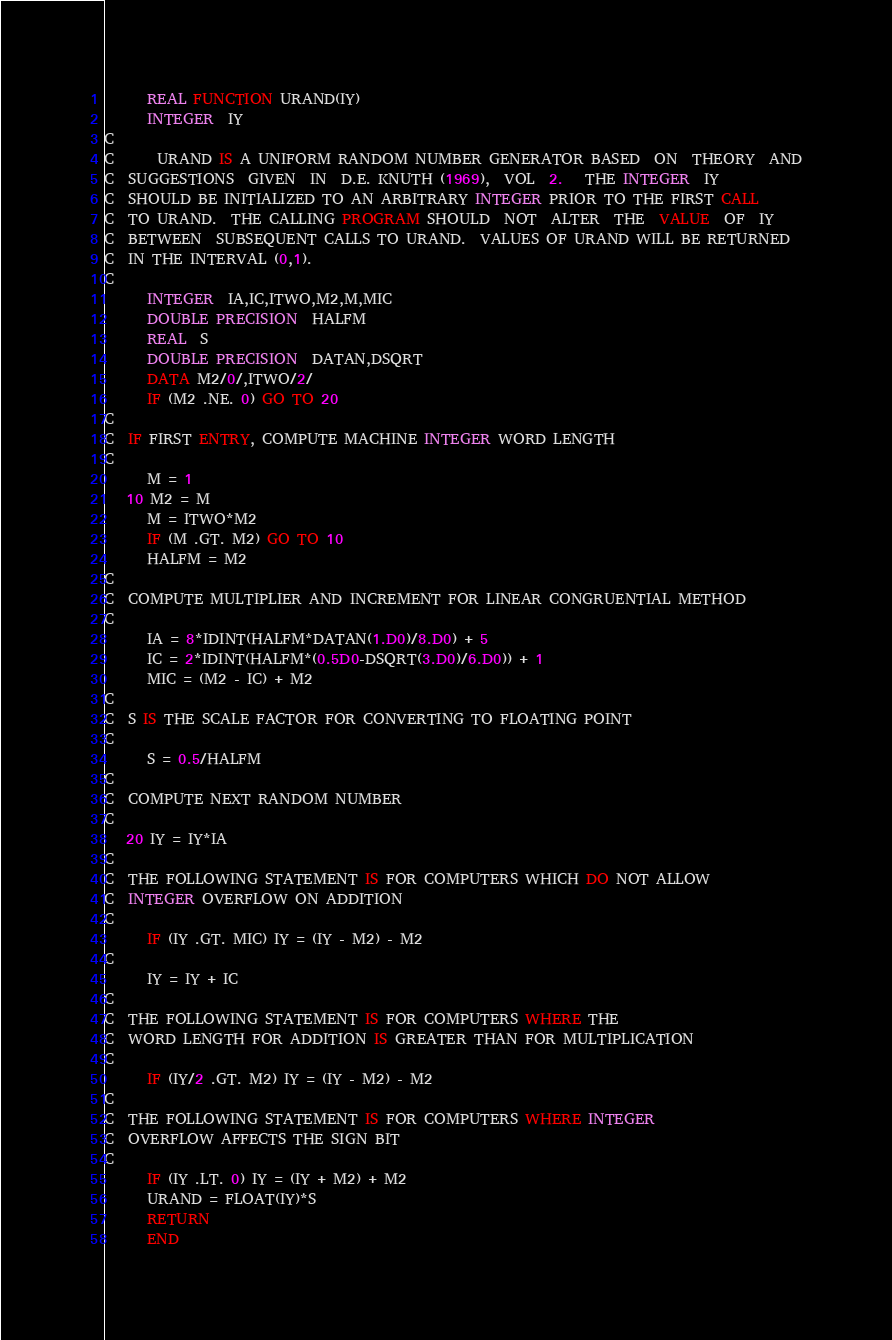Convert code to text. <code><loc_0><loc_0><loc_500><loc_500><_FORTRAN_>      REAL FUNCTION URAND(IY)
      INTEGER  IY
C
C      URAND IS A UNIFORM RANDOM NUMBER GENERATOR BASED  ON  THEORY  AND
C  SUGGESTIONS  GIVEN  IN  D.E. KNUTH (1969),  VOL  2.   THE INTEGER  IY
C  SHOULD BE INITIALIZED TO AN ARBITRARY INTEGER PRIOR TO THE FIRST CALL
C  TO URAND.  THE CALLING PROGRAM SHOULD  NOT  ALTER  THE  VALUE  OF  IY
C  BETWEEN  SUBSEQUENT CALLS TO URAND.  VALUES OF URAND WILL BE RETURNED
C  IN THE INTERVAL (0,1).
C
      INTEGER  IA,IC,ITWO,M2,M,MIC
      DOUBLE PRECISION  HALFM
      REAL  S
      DOUBLE PRECISION  DATAN,DSQRT
      DATA M2/0/,ITWO/2/
      IF (M2 .NE. 0) GO TO 20
C
C  IF FIRST ENTRY, COMPUTE MACHINE INTEGER WORD LENGTH
C
      M = 1
   10 M2 = M
      M = ITWO*M2
      IF (M .GT. M2) GO TO 10
      HALFM = M2
C
C  COMPUTE MULTIPLIER AND INCREMENT FOR LINEAR CONGRUENTIAL METHOD
C
      IA = 8*IDINT(HALFM*DATAN(1.D0)/8.D0) + 5
      IC = 2*IDINT(HALFM*(0.5D0-DSQRT(3.D0)/6.D0)) + 1
      MIC = (M2 - IC) + M2
C
C  S IS THE SCALE FACTOR FOR CONVERTING TO FLOATING POINT
C
      S = 0.5/HALFM
C
C  COMPUTE NEXT RANDOM NUMBER
C
   20 IY = IY*IA
C
C  THE FOLLOWING STATEMENT IS FOR COMPUTERS WHICH DO NOT ALLOW
C  INTEGER OVERFLOW ON ADDITION
C
      IF (IY .GT. MIC) IY = (IY - M2) - M2
C
      IY = IY + IC
C
C  THE FOLLOWING STATEMENT IS FOR COMPUTERS WHERE THE
C  WORD LENGTH FOR ADDITION IS GREATER THAN FOR MULTIPLICATION
C
      IF (IY/2 .GT. M2) IY = (IY - M2) - M2
C
C  THE FOLLOWING STATEMENT IS FOR COMPUTERS WHERE INTEGER
C  OVERFLOW AFFECTS THE SIGN BIT
C
      IF (IY .LT. 0) IY = (IY + M2) + M2
      URAND = FLOAT(IY)*S
      RETURN
      END
</code> 